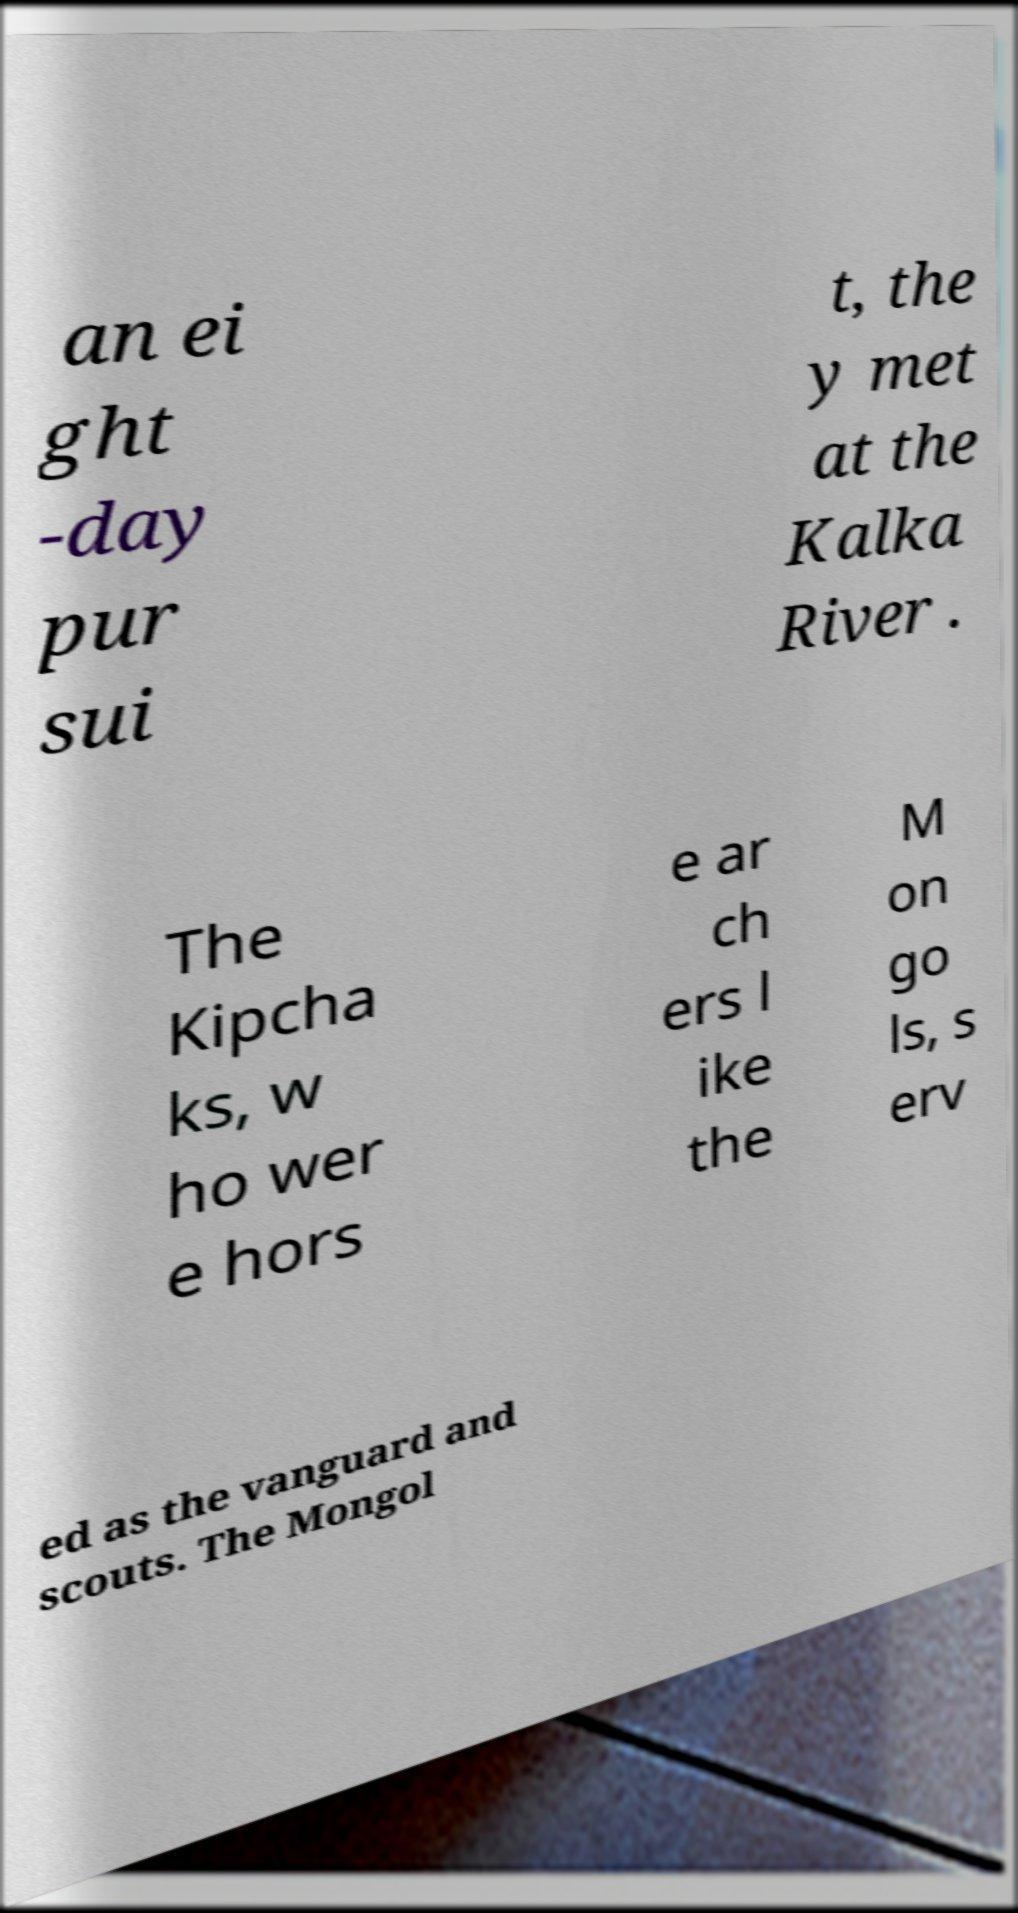Can you accurately transcribe the text from the provided image for me? an ei ght -day pur sui t, the y met at the Kalka River . The Kipcha ks, w ho wer e hors e ar ch ers l ike the M on go ls, s erv ed as the vanguard and scouts. The Mongol 